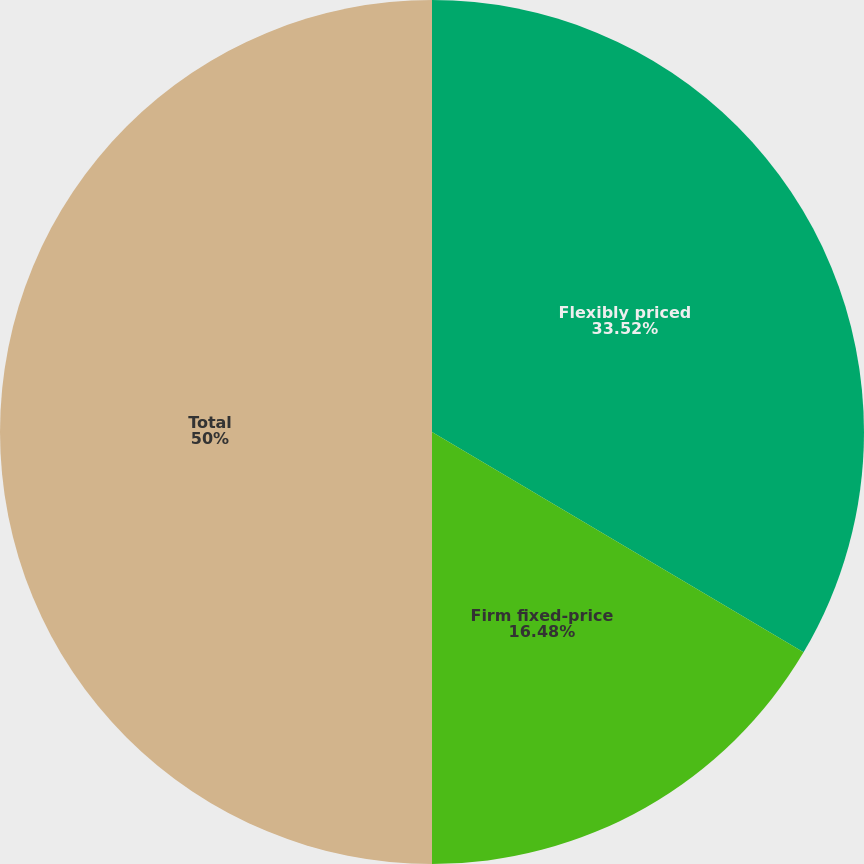Convert chart to OTSL. <chart><loc_0><loc_0><loc_500><loc_500><pie_chart><fcel>Flexibly priced<fcel>Firm fixed-price<fcel>Total<nl><fcel>33.52%<fcel>16.48%<fcel>50.0%<nl></chart> 